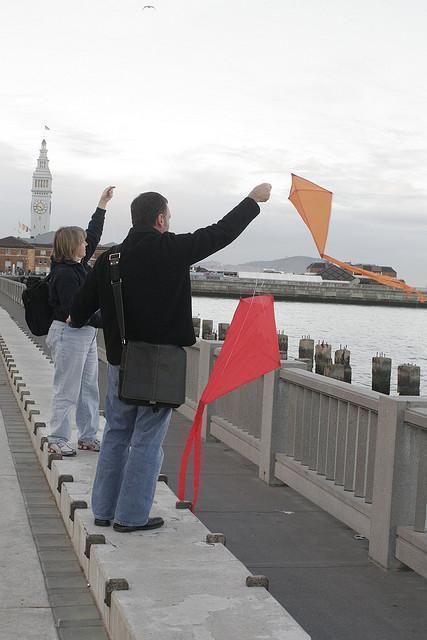How many kites can be seen?
Give a very brief answer. 2. How many people can you see?
Give a very brief answer. 2. 